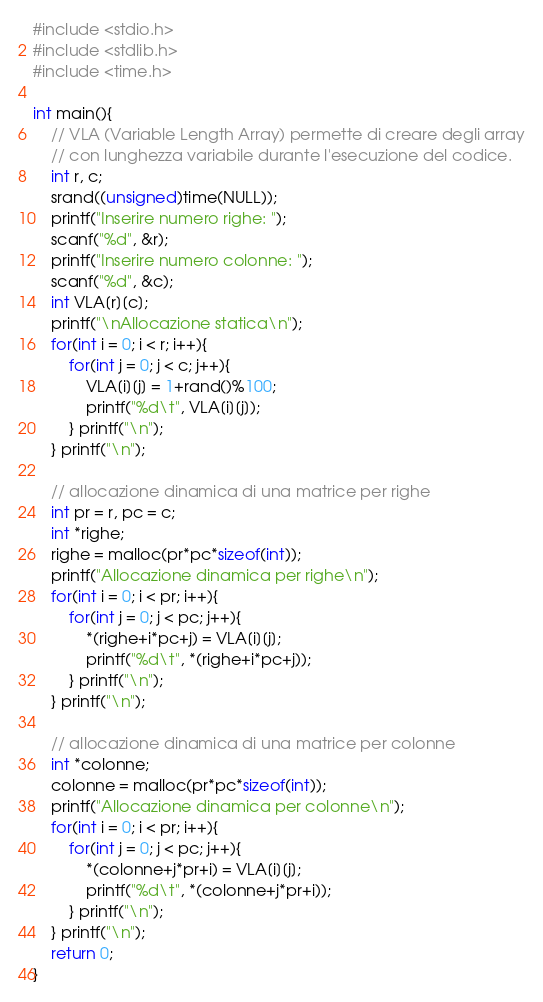<code> <loc_0><loc_0><loc_500><loc_500><_C_>#include <stdio.h>
#include <stdlib.h>
#include <time.h>

int main(){
    // VLA (Variable Length Array) permette di creare degli array
    // con lunghezza variabile durante l'esecuzione del codice.
    int r, c;
    srand((unsigned)time(NULL));
    printf("Inserire numero righe: ");
    scanf("%d", &r);
    printf("Inserire numero colonne: ");
    scanf("%d", &c);
    int VLA[r][c];
    printf("\nAllocazione statica\n");
    for(int i = 0; i < r; i++){
        for(int j = 0; j < c; j++){
            VLA[i][j] = 1+rand()%100;
            printf("%d\t", VLA[i][j]);
        } printf("\n");
    } printf("\n");

    // allocazione dinamica di una matrice per righe
    int pr = r, pc = c;
    int *righe;
    righe = malloc(pr*pc*sizeof(int));
    printf("Allocazione dinamica per righe\n");
    for(int i = 0; i < pr; i++){
        for(int j = 0; j < pc; j++){
            *(righe+i*pc+j) = VLA[i][j];
            printf("%d\t", *(righe+i*pc+j));
        } printf("\n");
    } printf("\n");

    // allocazione dinamica di una matrice per colonne
    int *colonne;
    colonne = malloc(pr*pc*sizeof(int));
    printf("Allocazione dinamica per colonne\n");
    for(int i = 0; i < pr; i++){
        for(int j = 0; j < pc; j++){
            *(colonne+j*pr+i) = VLA[i][j];
            printf("%d\t", *(colonne+j*pr+i));
        } printf("\n");
    } printf("\n");
    return 0;
}</code> 